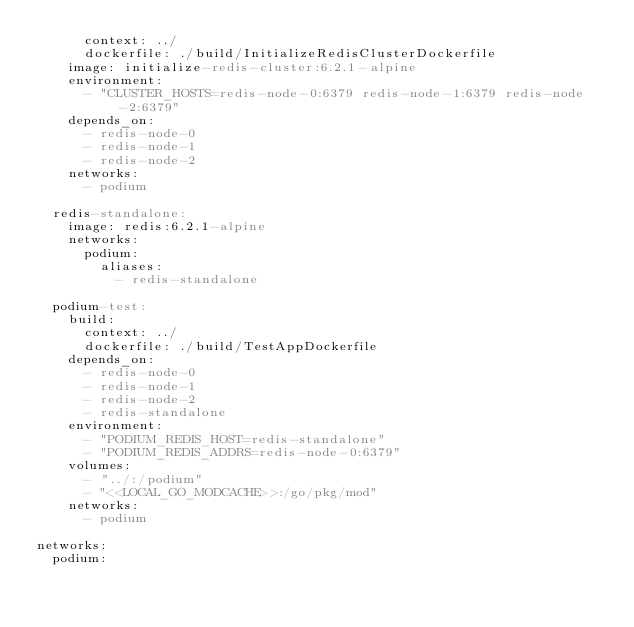<code> <loc_0><loc_0><loc_500><loc_500><_YAML_>      context: ../
      dockerfile: ./build/InitializeRedisClusterDockerfile
    image: initialize-redis-cluster:6.2.1-alpine
    environment:
      - "CLUSTER_HOSTS=redis-node-0:6379 redis-node-1:6379 redis-node-2:6379"
    depends_on:
      - redis-node-0
      - redis-node-1
      - redis-node-2
    networks:
      - podium

  redis-standalone:
    image: redis:6.2.1-alpine
    networks:
      podium:
        aliases:
          - redis-standalone

  podium-test:
    build:
      context: ../
      dockerfile: ./build/TestAppDockerfile
    depends_on:
      - redis-node-0
      - redis-node-1
      - redis-node-2
      - redis-standalone
    environment:
      - "PODIUM_REDIS_HOST=redis-standalone"
      - "PODIUM_REDIS_ADDRS=redis-node-0:6379"
    volumes:
      - "../:/podium"
      - "<<LOCAL_GO_MODCACHE>>:/go/pkg/mod"
    networks:
      - podium

networks:
  podium:
</code> 